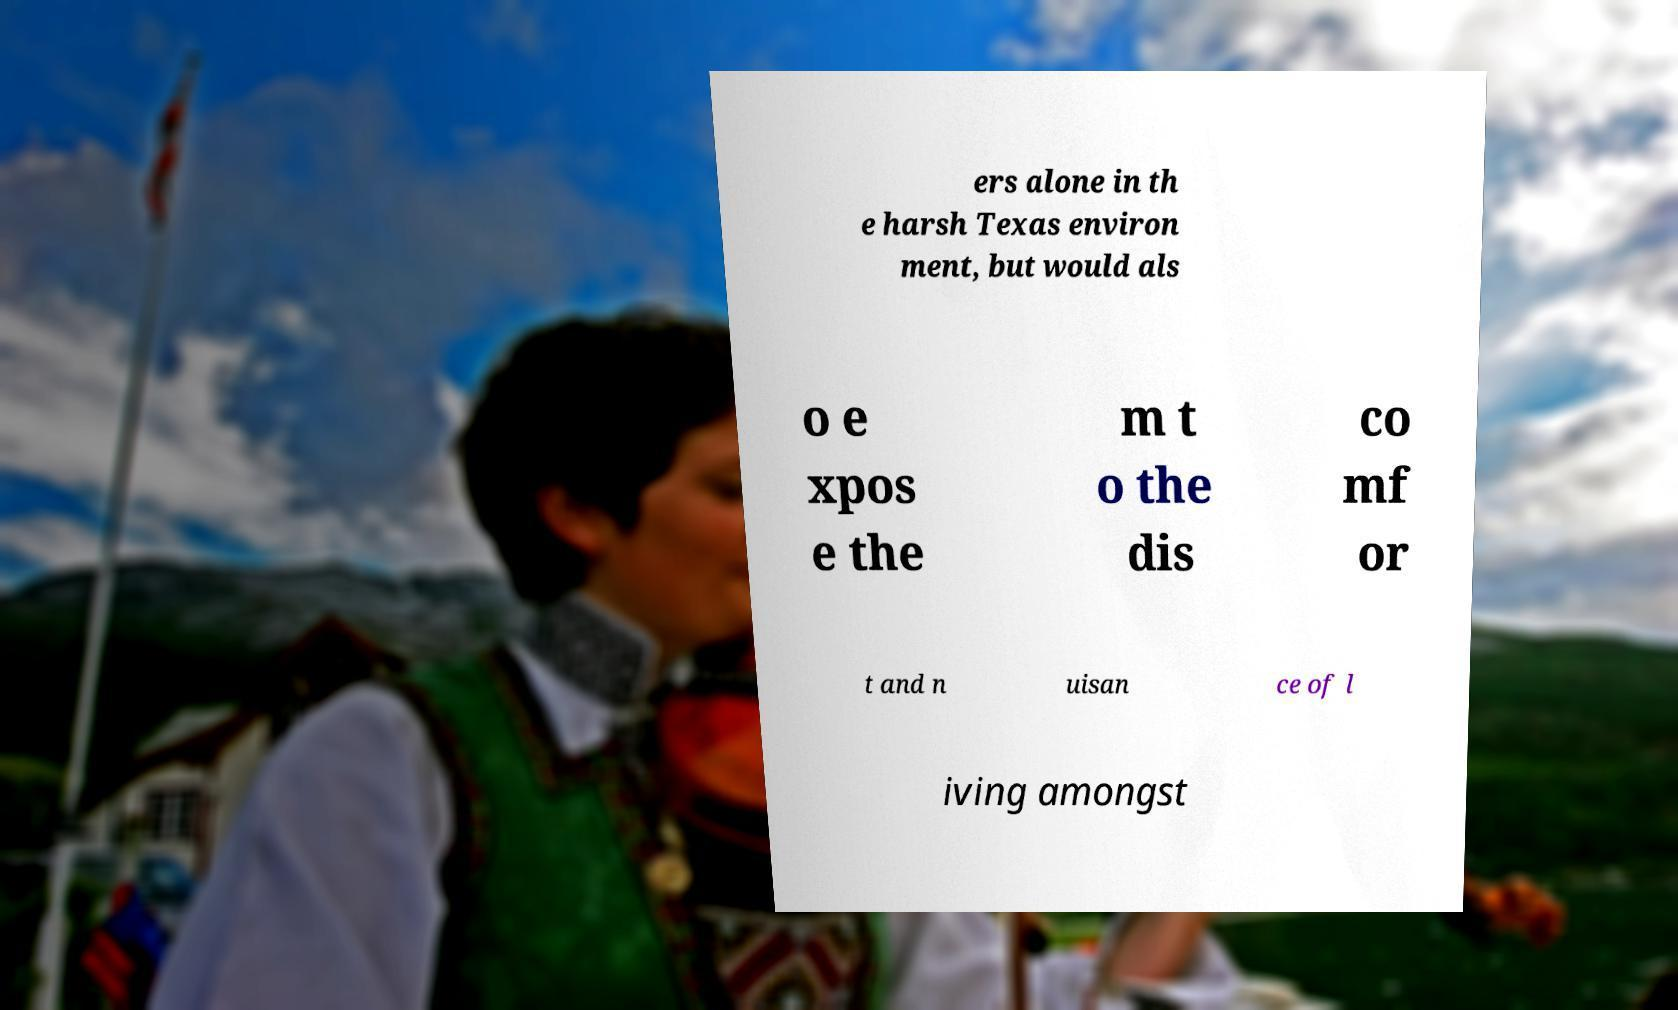Please identify and transcribe the text found in this image. ers alone in th e harsh Texas environ ment, but would als o e xpos e the m t o the dis co mf or t and n uisan ce of l iving amongst 